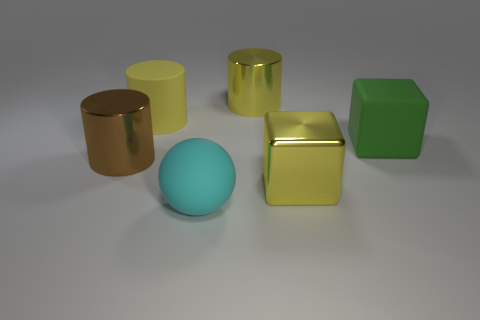What size is the metallic thing that is the same color as the shiny cube?
Provide a succinct answer. Large. What shape is the big cyan rubber thing?
Your answer should be very brief. Sphere. What is the shape of the matte thing that is in front of the big yellow metal object that is right of the cylinder on the right side of the cyan thing?
Provide a short and direct response. Sphere. What number of other objects are the same shape as the brown metal thing?
Provide a short and direct response. 2. What material is the big cyan ball in front of the large rubber thing that is on the right side of the big yellow block?
Your answer should be very brief. Rubber. Are there any other things that are the same size as the brown thing?
Ensure brevity in your answer.  Yes. Is the brown cylinder made of the same material as the large yellow thing that is in front of the brown metallic thing?
Your response must be concise. Yes. What material is the cylinder that is left of the sphere and behind the large green rubber thing?
Ensure brevity in your answer.  Rubber. What color is the big object that is in front of the large yellow object on the right side of the big yellow shiny cylinder?
Offer a terse response. Cyan. There is a large yellow object to the left of the sphere; what is its material?
Your answer should be very brief. Rubber. 